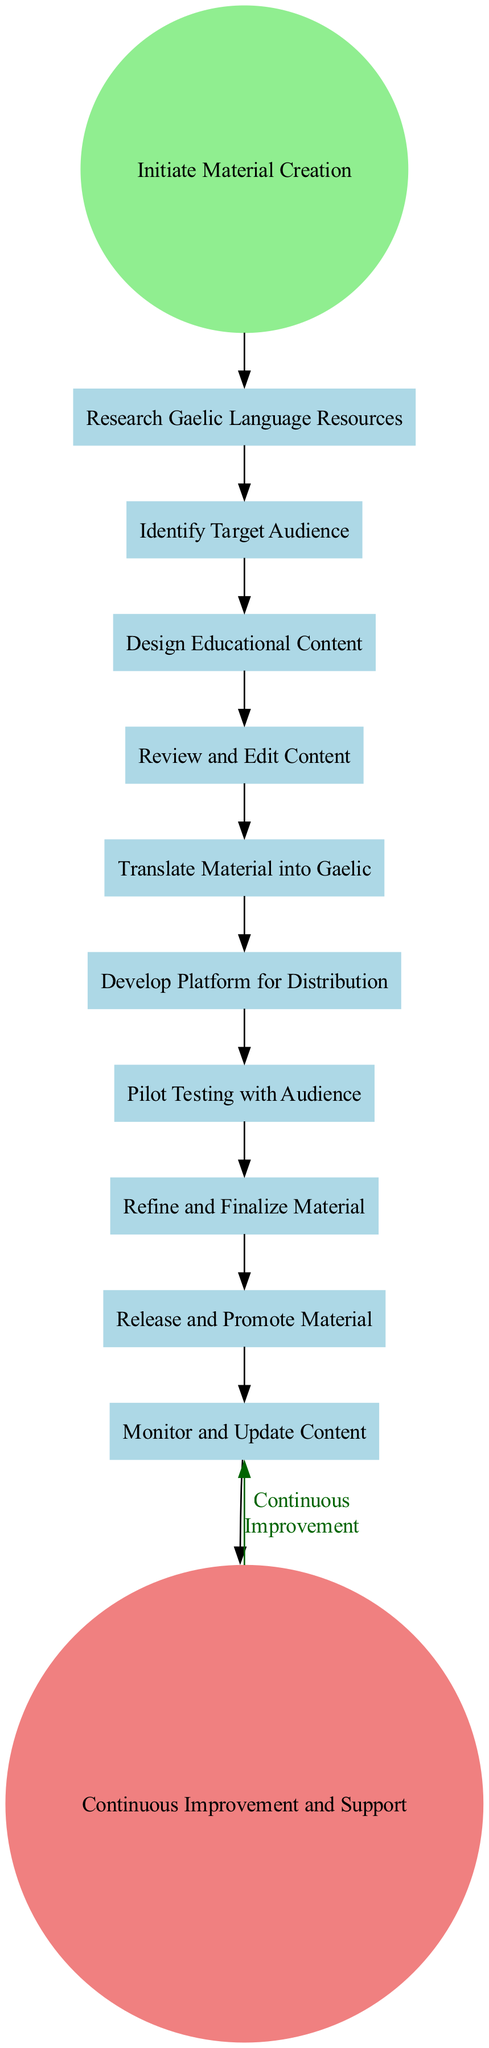What is the first activity in the diagram? The first activity is represented by the first rectangle node after the start event. According to the diagram, it is "Research Gaelic Language Resources."
Answer: Research Gaelic Language Resources How many activities are there in the diagram? To find the total number of activities, I count all the rectangle nodes listed in the diagram. There are 10 activities.
Answer: 10 What is the last activity before the end event? The last activity is found by checking the last rectangle node before the end event node. It is "Monitor and Update Content."
Answer: Monitor and Update Content What is the color of the start event node? The start event node is filled with light green color, which is specified in the node attributes.
Answer: light green What is the connection between "Pilot Testing with Audience" and "Refine and Finalize Material"? The connection is a directed edge that shows the flow from "Pilot Testing with Audience" to "Refine and Finalize Material," indicating that pilot testing leads to refining the material based on feedback.
Answer: directed edge How does the diagram represent continuous improvement? Continuous improvement is represented by a feedback loop that connects the end event back to "Release and Promote Material," demonstrating that the process repeats for ongoing updates.
Answer: feedback loop Which activity involves feedback from Gaelic language experts? The activity that involves feedback from Gaelic language experts is "Review and Edit Content," as it specifically mentions peer reviews and expert feedback.
Answer: Review and Edit Content What shape is used for activities in the diagram? All activities are represented as rectangle-shaped nodes, which is a common way to indicate tasks or processes in activity diagrams.
Answer: rectangle What is the purpose of the "Develop Platform for Distribution" activity? This activity focuses on establishing a means to disseminate the created educational material, ensuring it reaches the intended audience through various channels.
Answer: establish means for dissemination 